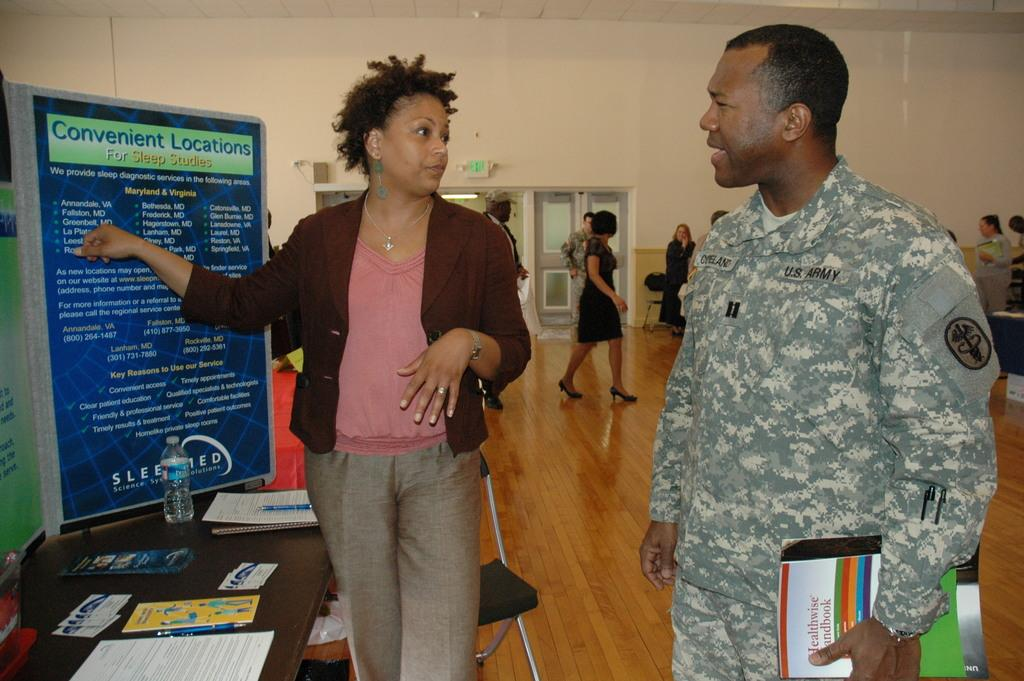What can be seen in the image involving people? There are people standing in the image. What is written on the board in the image? There is a board with text in the image. What type of object is visible near the people? There is a bottle visible in the image. What type of items are present that are typically used for learning or reading? There are books in the image. What is placed on a wooden surface in the image? There is paper placed on a wooden surface in the image. What type of feather can be seen in the image? There is no feather present in the image. What historical event is being discussed on the board in the image? The text on the board cannot be determined from the image, and there is no indication of a historical event being discussed. 